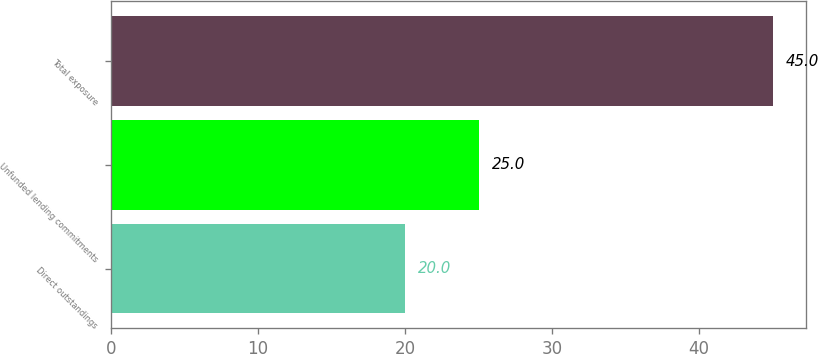<chart> <loc_0><loc_0><loc_500><loc_500><bar_chart><fcel>Direct outstandings<fcel>Unfunded lending commitments<fcel>Total exposure<nl><fcel>20<fcel>25<fcel>45<nl></chart> 